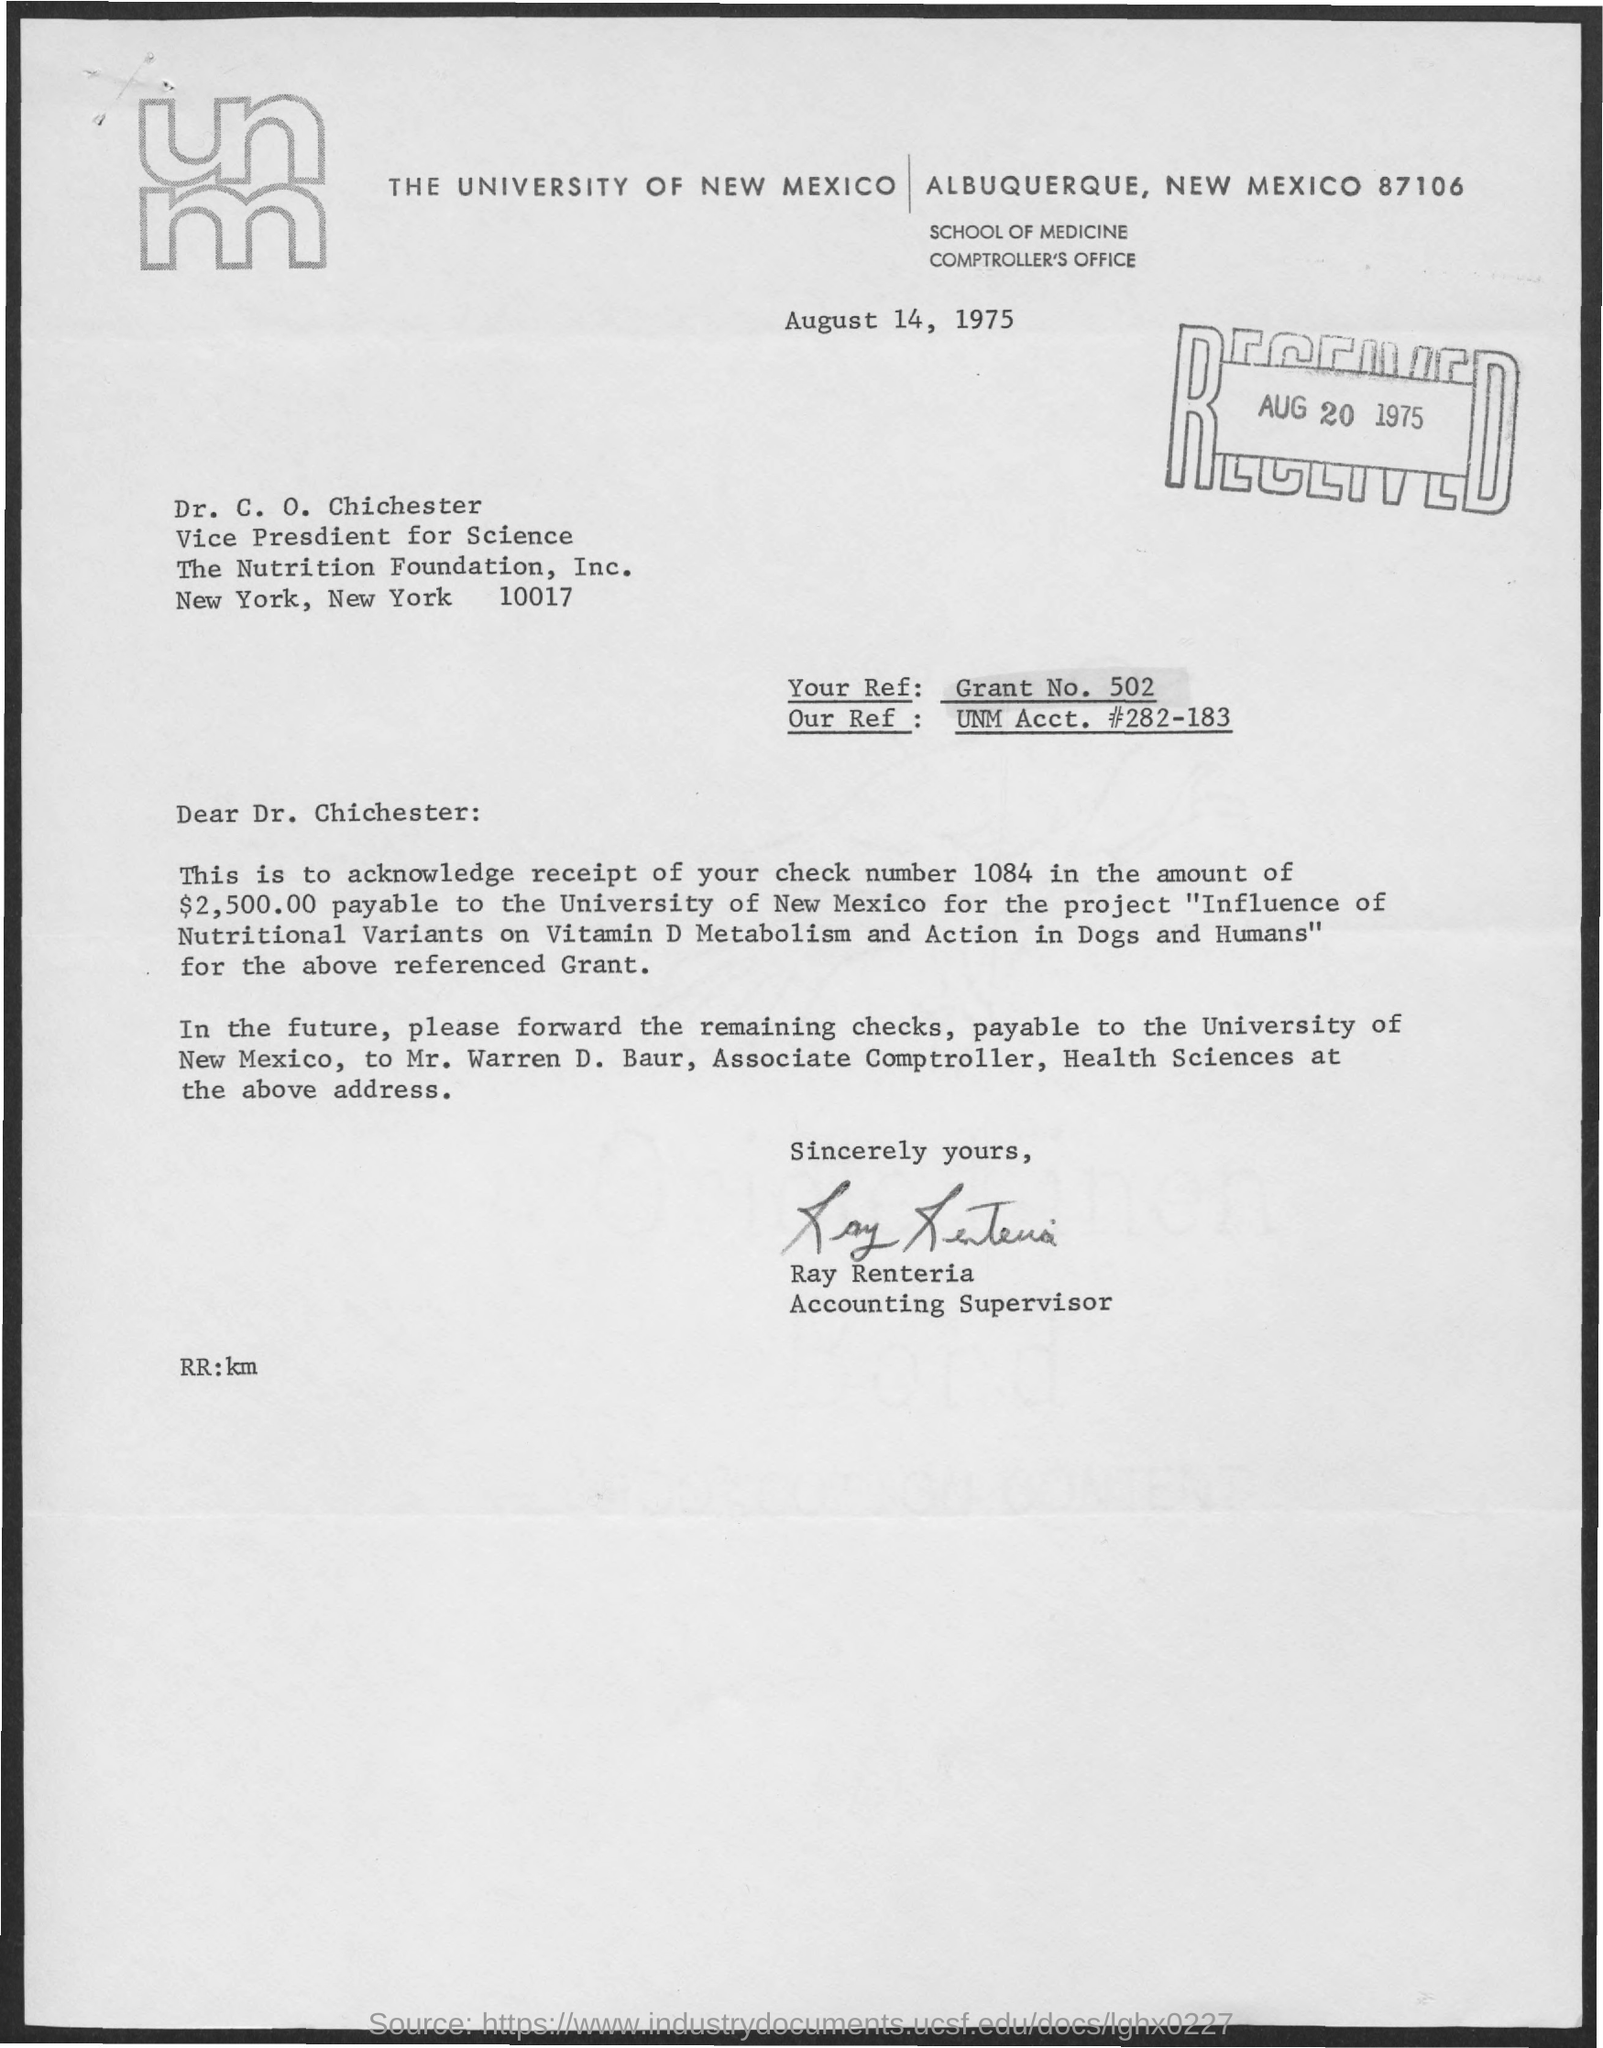Outline some significant characteristics in this image. Our Ref: UNM Acct. #282-183 refers to... The letter was received on August 20, 1975, as indicated in the date. The check number is 1084. Your Ref:" refers to a specific grant number with the prefix "502. The letter is from Ray Renteria. 